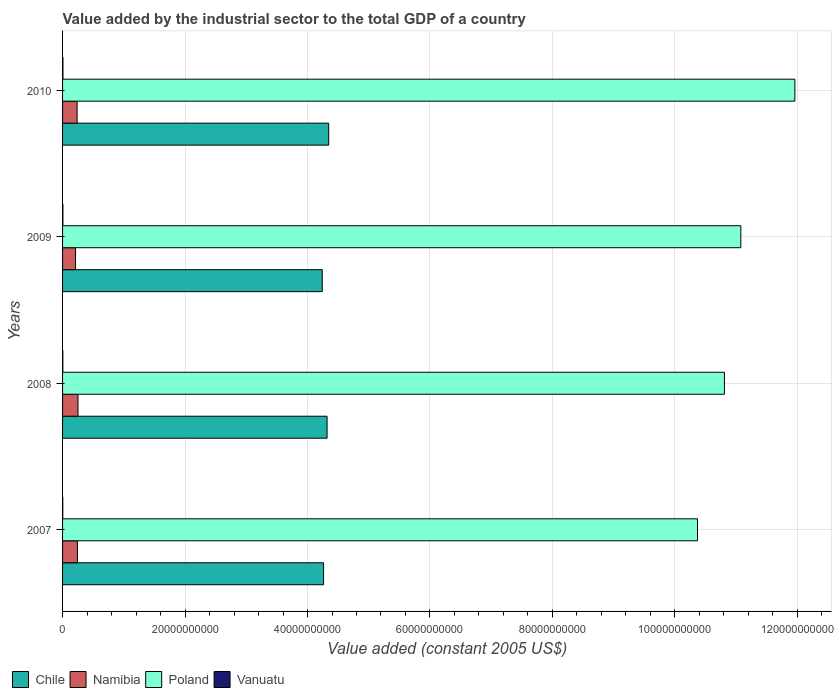How many different coloured bars are there?
Offer a terse response. 4. Are the number of bars on each tick of the Y-axis equal?
Make the answer very short. Yes. How many bars are there on the 2nd tick from the top?
Your answer should be very brief. 4. What is the label of the 1st group of bars from the top?
Your answer should be very brief. 2010. What is the value added by the industrial sector in Poland in 2010?
Keep it short and to the point. 1.20e+11. Across all years, what is the maximum value added by the industrial sector in Chile?
Your response must be concise. 4.35e+1. Across all years, what is the minimum value added by the industrial sector in Chile?
Your answer should be compact. 4.24e+1. In which year was the value added by the industrial sector in Vanuatu maximum?
Ensure brevity in your answer.  2010. What is the total value added by the industrial sector in Namibia in the graph?
Make the answer very short. 9.43e+09. What is the difference between the value added by the industrial sector in Vanuatu in 2008 and that in 2010?
Ensure brevity in your answer.  -1.94e+07. What is the difference between the value added by the industrial sector in Chile in 2010 and the value added by the industrial sector in Vanuatu in 2009?
Offer a terse response. 4.34e+1. What is the average value added by the industrial sector in Chile per year?
Offer a terse response. 4.29e+1. In the year 2009, what is the difference between the value added by the industrial sector in Namibia and value added by the industrial sector in Vanuatu?
Give a very brief answer. 2.06e+09. In how many years, is the value added by the industrial sector in Vanuatu greater than 108000000000 US$?
Give a very brief answer. 0. What is the ratio of the value added by the industrial sector in Vanuatu in 2007 to that in 2008?
Your answer should be very brief. 0.78. What is the difference between the highest and the second highest value added by the industrial sector in Namibia?
Ensure brevity in your answer.  9.46e+07. What is the difference between the highest and the lowest value added by the industrial sector in Namibia?
Ensure brevity in your answer.  4.00e+08. Is the sum of the value added by the industrial sector in Vanuatu in 2007 and 2008 greater than the maximum value added by the industrial sector in Poland across all years?
Give a very brief answer. No. Is it the case that in every year, the sum of the value added by the industrial sector in Poland and value added by the industrial sector in Vanuatu is greater than the sum of value added by the industrial sector in Chile and value added by the industrial sector in Namibia?
Keep it short and to the point. Yes. What does the 2nd bar from the top in 2009 represents?
Your response must be concise. Poland. Are the values on the major ticks of X-axis written in scientific E-notation?
Offer a terse response. No. Does the graph contain grids?
Offer a terse response. Yes. How many legend labels are there?
Offer a very short reply. 4. How are the legend labels stacked?
Your response must be concise. Horizontal. What is the title of the graph?
Your response must be concise. Value added by the industrial sector to the total GDP of a country. Does "Kenya" appear as one of the legend labels in the graph?
Offer a very short reply. No. What is the label or title of the X-axis?
Keep it short and to the point. Value added (constant 2005 US$). What is the Value added (constant 2005 US$) in Chile in 2007?
Give a very brief answer. 4.26e+1. What is the Value added (constant 2005 US$) in Namibia in 2007?
Make the answer very short. 2.42e+09. What is the Value added (constant 2005 US$) in Poland in 2007?
Offer a terse response. 1.04e+11. What is the Value added (constant 2005 US$) in Vanuatu in 2007?
Offer a very short reply. 3.48e+07. What is the Value added (constant 2005 US$) in Chile in 2008?
Your answer should be very brief. 4.32e+1. What is the Value added (constant 2005 US$) of Namibia in 2008?
Make the answer very short. 2.52e+09. What is the Value added (constant 2005 US$) of Poland in 2008?
Your response must be concise. 1.08e+11. What is the Value added (constant 2005 US$) of Vanuatu in 2008?
Your response must be concise. 4.44e+07. What is the Value added (constant 2005 US$) of Chile in 2009?
Your answer should be compact. 4.24e+1. What is the Value added (constant 2005 US$) of Namibia in 2009?
Offer a terse response. 2.12e+09. What is the Value added (constant 2005 US$) in Poland in 2009?
Offer a very short reply. 1.11e+11. What is the Value added (constant 2005 US$) in Vanuatu in 2009?
Offer a very short reply. 5.66e+07. What is the Value added (constant 2005 US$) in Chile in 2010?
Your answer should be very brief. 4.35e+1. What is the Value added (constant 2005 US$) in Namibia in 2010?
Your response must be concise. 2.37e+09. What is the Value added (constant 2005 US$) of Poland in 2010?
Make the answer very short. 1.20e+11. What is the Value added (constant 2005 US$) in Vanuatu in 2010?
Make the answer very short. 6.38e+07. Across all years, what is the maximum Value added (constant 2005 US$) of Chile?
Provide a succinct answer. 4.35e+1. Across all years, what is the maximum Value added (constant 2005 US$) of Namibia?
Your response must be concise. 2.52e+09. Across all years, what is the maximum Value added (constant 2005 US$) of Poland?
Make the answer very short. 1.20e+11. Across all years, what is the maximum Value added (constant 2005 US$) of Vanuatu?
Offer a very short reply. 6.38e+07. Across all years, what is the minimum Value added (constant 2005 US$) in Chile?
Offer a terse response. 4.24e+1. Across all years, what is the minimum Value added (constant 2005 US$) in Namibia?
Offer a very short reply. 2.12e+09. Across all years, what is the minimum Value added (constant 2005 US$) in Poland?
Give a very brief answer. 1.04e+11. Across all years, what is the minimum Value added (constant 2005 US$) in Vanuatu?
Your answer should be compact. 3.48e+07. What is the total Value added (constant 2005 US$) in Chile in the graph?
Provide a short and direct response. 1.72e+11. What is the total Value added (constant 2005 US$) in Namibia in the graph?
Your response must be concise. 9.43e+09. What is the total Value added (constant 2005 US$) in Poland in the graph?
Keep it short and to the point. 4.42e+11. What is the total Value added (constant 2005 US$) in Vanuatu in the graph?
Your answer should be very brief. 2.00e+08. What is the difference between the Value added (constant 2005 US$) in Chile in 2007 and that in 2008?
Offer a very short reply. -5.74e+08. What is the difference between the Value added (constant 2005 US$) of Namibia in 2007 and that in 2008?
Your answer should be very brief. -9.46e+07. What is the difference between the Value added (constant 2005 US$) of Poland in 2007 and that in 2008?
Offer a very short reply. -4.40e+09. What is the difference between the Value added (constant 2005 US$) in Vanuatu in 2007 and that in 2008?
Offer a very short reply. -9.58e+06. What is the difference between the Value added (constant 2005 US$) of Chile in 2007 and that in 2009?
Provide a succinct answer. 2.17e+08. What is the difference between the Value added (constant 2005 US$) in Namibia in 2007 and that in 2009?
Your answer should be compact. 3.05e+08. What is the difference between the Value added (constant 2005 US$) of Poland in 2007 and that in 2009?
Make the answer very short. -7.07e+09. What is the difference between the Value added (constant 2005 US$) of Vanuatu in 2007 and that in 2009?
Provide a succinct answer. -2.18e+07. What is the difference between the Value added (constant 2005 US$) of Chile in 2007 and that in 2010?
Ensure brevity in your answer.  -8.36e+08. What is the difference between the Value added (constant 2005 US$) of Namibia in 2007 and that in 2010?
Provide a short and direct response. 4.95e+07. What is the difference between the Value added (constant 2005 US$) of Poland in 2007 and that in 2010?
Offer a very short reply. -1.59e+1. What is the difference between the Value added (constant 2005 US$) in Vanuatu in 2007 and that in 2010?
Offer a terse response. -2.90e+07. What is the difference between the Value added (constant 2005 US$) in Chile in 2008 and that in 2009?
Ensure brevity in your answer.  7.91e+08. What is the difference between the Value added (constant 2005 US$) of Namibia in 2008 and that in 2009?
Provide a short and direct response. 4.00e+08. What is the difference between the Value added (constant 2005 US$) of Poland in 2008 and that in 2009?
Give a very brief answer. -2.67e+09. What is the difference between the Value added (constant 2005 US$) in Vanuatu in 2008 and that in 2009?
Offer a terse response. -1.23e+07. What is the difference between the Value added (constant 2005 US$) in Chile in 2008 and that in 2010?
Offer a terse response. -2.62e+08. What is the difference between the Value added (constant 2005 US$) in Namibia in 2008 and that in 2010?
Your response must be concise. 1.44e+08. What is the difference between the Value added (constant 2005 US$) in Poland in 2008 and that in 2010?
Offer a terse response. -1.15e+1. What is the difference between the Value added (constant 2005 US$) in Vanuatu in 2008 and that in 2010?
Offer a terse response. -1.94e+07. What is the difference between the Value added (constant 2005 US$) in Chile in 2009 and that in 2010?
Offer a terse response. -1.05e+09. What is the difference between the Value added (constant 2005 US$) in Namibia in 2009 and that in 2010?
Give a very brief answer. -2.56e+08. What is the difference between the Value added (constant 2005 US$) in Poland in 2009 and that in 2010?
Provide a succinct answer. -8.83e+09. What is the difference between the Value added (constant 2005 US$) in Vanuatu in 2009 and that in 2010?
Provide a succinct answer. -7.15e+06. What is the difference between the Value added (constant 2005 US$) in Chile in 2007 and the Value added (constant 2005 US$) in Namibia in 2008?
Ensure brevity in your answer.  4.01e+1. What is the difference between the Value added (constant 2005 US$) in Chile in 2007 and the Value added (constant 2005 US$) in Poland in 2008?
Provide a succinct answer. -6.55e+1. What is the difference between the Value added (constant 2005 US$) in Chile in 2007 and the Value added (constant 2005 US$) in Vanuatu in 2008?
Your response must be concise. 4.26e+1. What is the difference between the Value added (constant 2005 US$) in Namibia in 2007 and the Value added (constant 2005 US$) in Poland in 2008?
Your answer should be very brief. -1.06e+11. What is the difference between the Value added (constant 2005 US$) of Namibia in 2007 and the Value added (constant 2005 US$) of Vanuatu in 2008?
Offer a terse response. 2.38e+09. What is the difference between the Value added (constant 2005 US$) in Poland in 2007 and the Value added (constant 2005 US$) in Vanuatu in 2008?
Keep it short and to the point. 1.04e+11. What is the difference between the Value added (constant 2005 US$) in Chile in 2007 and the Value added (constant 2005 US$) in Namibia in 2009?
Your answer should be compact. 4.05e+1. What is the difference between the Value added (constant 2005 US$) of Chile in 2007 and the Value added (constant 2005 US$) of Poland in 2009?
Provide a short and direct response. -6.81e+1. What is the difference between the Value added (constant 2005 US$) in Chile in 2007 and the Value added (constant 2005 US$) in Vanuatu in 2009?
Make the answer very short. 4.26e+1. What is the difference between the Value added (constant 2005 US$) in Namibia in 2007 and the Value added (constant 2005 US$) in Poland in 2009?
Your response must be concise. -1.08e+11. What is the difference between the Value added (constant 2005 US$) in Namibia in 2007 and the Value added (constant 2005 US$) in Vanuatu in 2009?
Offer a terse response. 2.37e+09. What is the difference between the Value added (constant 2005 US$) in Poland in 2007 and the Value added (constant 2005 US$) in Vanuatu in 2009?
Give a very brief answer. 1.04e+11. What is the difference between the Value added (constant 2005 US$) of Chile in 2007 and the Value added (constant 2005 US$) of Namibia in 2010?
Offer a very short reply. 4.02e+1. What is the difference between the Value added (constant 2005 US$) of Chile in 2007 and the Value added (constant 2005 US$) of Poland in 2010?
Provide a succinct answer. -7.70e+1. What is the difference between the Value added (constant 2005 US$) of Chile in 2007 and the Value added (constant 2005 US$) of Vanuatu in 2010?
Provide a short and direct response. 4.26e+1. What is the difference between the Value added (constant 2005 US$) in Namibia in 2007 and the Value added (constant 2005 US$) in Poland in 2010?
Provide a succinct answer. -1.17e+11. What is the difference between the Value added (constant 2005 US$) in Namibia in 2007 and the Value added (constant 2005 US$) in Vanuatu in 2010?
Provide a short and direct response. 2.36e+09. What is the difference between the Value added (constant 2005 US$) in Poland in 2007 and the Value added (constant 2005 US$) in Vanuatu in 2010?
Offer a very short reply. 1.04e+11. What is the difference between the Value added (constant 2005 US$) of Chile in 2008 and the Value added (constant 2005 US$) of Namibia in 2009?
Keep it short and to the point. 4.11e+1. What is the difference between the Value added (constant 2005 US$) of Chile in 2008 and the Value added (constant 2005 US$) of Poland in 2009?
Give a very brief answer. -6.76e+1. What is the difference between the Value added (constant 2005 US$) in Chile in 2008 and the Value added (constant 2005 US$) in Vanuatu in 2009?
Your response must be concise. 4.31e+1. What is the difference between the Value added (constant 2005 US$) of Namibia in 2008 and the Value added (constant 2005 US$) of Poland in 2009?
Keep it short and to the point. -1.08e+11. What is the difference between the Value added (constant 2005 US$) in Namibia in 2008 and the Value added (constant 2005 US$) in Vanuatu in 2009?
Ensure brevity in your answer.  2.46e+09. What is the difference between the Value added (constant 2005 US$) in Poland in 2008 and the Value added (constant 2005 US$) in Vanuatu in 2009?
Your answer should be compact. 1.08e+11. What is the difference between the Value added (constant 2005 US$) in Chile in 2008 and the Value added (constant 2005 US$) in Namibia in 2010?
Provide a short and direct response. 4.08e+1. What is the difference between the Value added (constant 2005 US$) of Chile in 2008 and the Value added (constant 2005 US$) of Poland in 2010?
Offer a very short reply. -7.64e+1. What is the difference between the Value added (constant 2005 US$) of Chile in 2008 and the Value added (constant 2005 US$) of Vanuatu in 2010?
Your response must be concise. 4.31e+1. What is the difference between the Value added (constant 2005 US$) of Namibia in 2008 and the Value added (constant 2005 US$) of Poland in 2010?
Offer a terse response. -1.17e+11. What is the difference between the Value added (constant 2005 US$) in Namibia in 2008 and the Value added (constant 2005 US$) in Vanuatu in 2010?
Your response must be concise. 2.45e+09. What is the difference between the Value added (constant 2005 US$) of Poland in 2008 and the Value added (constant 2005 US$) of Vanuatu in 2010?
Offer a terse response. 1.08e+11. What is the difference between the Value added (constant 2005 US$) in Chile in 2009 and the Value added (constant 2005 US$) in Namibia in 2010?
Offer a terse response. 4.00e+1. What is the difference between the Value added (constant 2005 US$) in Chile in 2009 and the Value added (constant 2005 US$) in Poland in 2010?
Your response must be concise. -7.72e+1. What is the difference between the Value added (constant 2005 US$) of Chile in 2009 and the Value added (constant 2005 US$) of Vanuatu in 2010?
Provide a short and direct response. 4.23e+1. What is the difference between the Value added (constant 2005 US$) of Namibia in 2009 and the Value added (constant 2005 US$) of Poland in 2010?
Your answer should be compact. -1.17e+11. What is the difference between the Value added (constant 2005 US$) of Namibia in 2009 and the Value added (constant 2005 US$) of Vanuatu in 2010?
Give a very brief answer. 2.05e+09. What is the difference between the Value added (constant 2005 US$) in Poland in 2009 and the Value added (constant 2005 US$) in Vanuatu in 2010?
Give a very brief answer. 1.11e+11. What is the average Value added (constant 2005 US$) of Chile per year?
Your answer should be compact. 4.29e+1. What is the average Value added (constant 2005 US$) in Namibia per year?
Your answer should be compact. 2.36e+09. What is the average Value added (constant 2005 US$) of Poland per year?
Ensure brevity in your answer.  1.11e+11. What is the average Value added (constant 2005 US$) of Vanuatu per year?
Offer a terse response. 4.99e+07. In the year 2007, what is the difference between the Value added (constant 2005 US$) in Chile and Value added (constant 2005 US$) in Namibia?
Your answer should be compact. 4.02e+1. In the year 2007, what is the difference between the Value added (constant 2005 US$) in Chile and Value added (constant 2005 US$) in Poland?
Give a very brief answer. -6.11e+1. In the year 2007, what is the difference between the Value added (constant 2005 US$) of Chile and Value added (constant 2005 US$) of Vanuatu?
Your response must be concise. 4.26e+1. In the year 2007, what is the difference between the Value added (constant 2005 US$) of Namibia and Value added (constant 2005 US$) of Poland?
Give a very brief answer. -1.01e+11. In the year 2007, what is the difference between the Value added (constant 2005 US$) in Namibia and Value added (constant 2005 US$) in Vanuatu?
Your answer should be compact. 2.39e+09. In the year 2007, what is the difference between the Value added (constant 2005 US$) in Poland and Value added (constant 2005 US$) in Vanuatu?
Offer a terse response. 1.04e+11. In the year 2008, what is the difference between the Value added (constant 2005 US$) in Chile and Value added (constant 2005 US$) in Namibia?
Ensure brevity in your answer.  4.07e+1. In the year 2008, what is the difference between the Value added (constant 2005 US$) in Chile and Value added (constant 2005 US$) in Poland?
Your answer should be compact. -6.49e+1. In the year 2008, what is the difference between the Value added (constant 2005 US$) in Chile and Value added (constant 2005 US$) in Vanuatu?
Give a very brief answer. 4.32e+1. In the year 2008, what is the difference between the Value added (constant 2005 US$) in Namibia and Value added (constant 2005 US$) in Poland?
Your answer should be compact. -1.06e+11. In the year 2008, what is the difference between the Value added (constant 2005 US$) of Namibia and Value added (constant 2005 US$) of Vanuatu?
Give a very brief answer. 2.47e+09. In the year 2008, what is the difference between the Value added (constant 2005 US$) in Poland and Value added (constant 2005 US$) in Vanuatu?
Your response must be concise. 1.08e+11. In the year 2009, what is the difference between the Value added (constant 2005 US$) in Chile and Value added (constant 2005 US$) in Namibia?
Give a very brief answer. 4.03e+1. In the year 2009, what is the difference between the Value added (constant 2005 US$) in Chile and Value added (constant 2005 US$) in Poland?
Give a very brief answer. -6.84e+1. In the year 2009, what is the difference between the Value added (constant 2005 US$) of Chile and Value added (constant 2005 US$) of Vanuatu?
Provide a succinct answer. 4.23e+1. In the year 2009, what is the difference between the Value added (constant 2005 US$) in Namibia and Value added (constant 2005 US$) in Poland?
Offer a very short reply. -1.09e+11. In the year 2009, what is the difference between the Value added (constant 2005 US$) in Namibia and Value added (constant 2005 US$) in Vanuatu?
Offer a very short reply. 2.06e+09. In the year 2009, what is the difference between the Value added (constant 2005 US$) in Poland and Value added (constant 2005 US$) in Vanuatu?
Offer a terse response. 1.11e+11. In the year 2010, what is the difference between the Value added (constant 2005 US$) in Chile and Value added (constant 2005 US$) in Namibia?
Ensure brevity in your answer.  4.11e+1. In the year 2010, what is the difference between the Value added (constant 2005 US$) in Chile and Value added (constant 2005 US$) in Poland?
Your response must be concise. -7.61e+1. In the year 2010, what is the difference between the Value added (constant 2005 US$) of Chile and Value added (constant 2005 US$) of Vanuatu?
Your answer should be compact. 4.34e+1. In the year 2010, what is the difference between the Value added (constant 2005 US$) of Namibia and Value added (constant 2005 US$) of Poland?
Provide a succinct answer. -1.17e+11. In the year 2010, what is the difference between the Value added (constant 2005 US$) of Namibia and Value added (constant 2005 US$) of Vanuatu?
Your answer should be very brief. 2.31e+09. In the year 2010, what is the difference between the Value added (constant 2005 US$) of Poland and Value added (constant 2005 US$) of Vanuatu?
Provide a short and direct response. 1.20e+11. What is the ratio of the Value added (constant 2005 US$) in Chile in 2007 to that in 2008?
Offer a terse response. 0.99. What is the ratio of the Value added (constant 2005 US$) in Namibia in 2007 to that in 2008?
Make the answer very short. 0.96. What is the ratio of the Value added (constant 2005 US$) in Poland in 2007 to that in 2008?
Your answer should be compact. 0.96. What is the ratio of the Value added (constant 2005 US$) in Vanuatu in 2007 to that in 2008?
Provide a succinct answer. 0.78. What is the ratio of the Value added (constant 2005 US$) in Namibia in 2007 to that in 2009?
Your response must be concise. 1.14. What is the ratio of the Value added (constant 2005 US$) in Poland in 2007 to that in 2009?
Your response must be concise. 0.94. What is the ratio of the Value added (constant 2005 US$) in Vanuatu in 2007 to that in 2009?
Keep it short and to the point. 0.61. What is the ratio of the Value added (constant 2005 US$) in Chile in 2007 to that in 2010?
Ensure brevity in your answer.  0.98. What is the ratio of the Value added (constant 2005 US$) of Namibia in 2007 to that in 2010?
Your answer should be compact. 1.02. What is the ratio of the Value added (constant 2005 US$) of Poland in 2007 to that in 2010?
Your answer should be compact. 0.87. What is the ratio of the Value added (constant 2005 US$) in Vanuatu in 2007 to that in 2010?
Provide a short and direct response. 0.55. What is the ratio of the Value added (constant 2005 US$) of Chile in 2008 to that in 2009?
Offer a very short reply. 1.02. What is the ratio of the Value added (constant 2005 US$) in Namibia in 2008 to that in 2009?
Your answer should be compact. 1.19. What is the ratio of the Value added (constant 2005 US$) in Poland in 2008 to that in 2009?
Your answer should be compact. 0.98. What is the ratio of the Value added (constant 2005 US$) in Vanuatu in 2008 to that in 2009?
Give a very brief answer. 0.78. What is the ratio of the Value added (constant 2005 US$) in Chile in 2008 to that in 2010?
Offer a very short reply. 0.99. What is the ratio of the Value added (constant 2005 US$) of Namibia in 2008 to that in 2010?
Provide a succinct answer. 1.06. What is the ratio of the Value added (constant 2005 US$) of Poland in 2008 to that in 2010?
Provide a short and direct response. 0.9. What is the ratio of the Value added (constant 2005 US$) in Vanuatu in 2008 to that in 2010?
Your response must be concise. 0.7. What is the ratio of the Value added (constant 2005 US$) of Chile in 2009 to that in 2010?
Make the answer very short. 0.98. What is the ratio of the Value added (constant 2005 US$) in Namibia in 2009 to that in 2010?
Your answer should be very brief. 0.89. What is the ratio of the Value added (constant 2005 US$) of Poland in 2009 to that in 2010?
Provide a succinct answer. 0.93. What is the ratio of the Value added (constant 2005 US$) of Vanuatu in 2009 to that in 2010?
Offer a very short reply. 0.89. What is the difference between the highest and the second highest Value added (constant 2005 US$) of Chile?
Give a very brief answer. 2.62e+08. What is the difference between the highest and the second highest Value added (constant 2005 US$) of Namibia?
Make the answer very short. 9.46e+07. What is the difference between the highest and the second highest Value added (constant 2005 US$) in Poland?
Your answer should be compact. 8.83e+09. What is the difference between the highest and the second highest Value added (constant 2005 US$) of Vanuatu?
Offer a terse response. 7.15e+06. What is the difference between the highest and the lowest Value added (constant 2005 US$) of Chile?
Provide a succinct answer. 1.05e+09. What is the difference between the highest and the lowest Value added (constant 2005 US$) in Namibia?
Make the answer very short. 4.00e+08. What is the difference between the highest and the lowest Value added (constant 2005 US$) in Poland?
Provide a short and direct response. 1.59e+1. What is the difference between the highest and the lowest Value added (constant 2005 US$) in Vanuatu?
Give a very brief answer. 2.90e+07. 